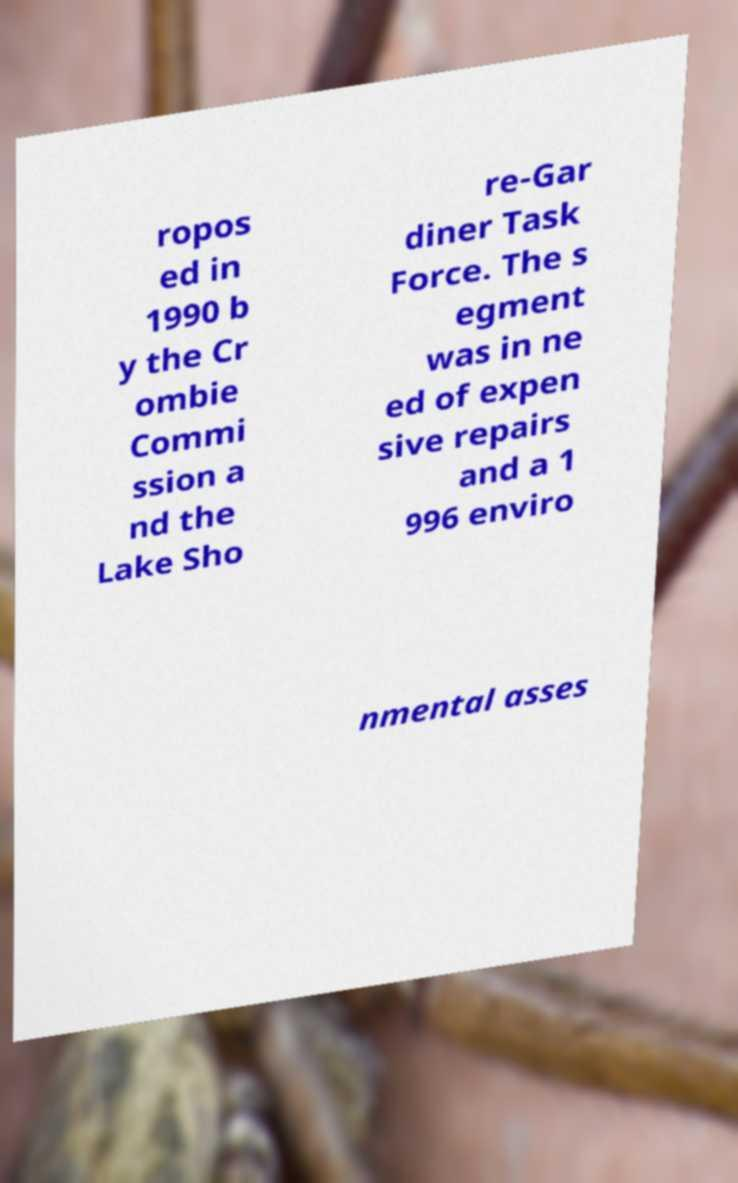I need the written content from this picture converted into text. Can you do that? ropos ed in 1990 b y the Cr ombie Commi ssion a nd the Lake Sho re-Gar diner Task Force. The s egment was in ne ed of expen sive repairs and a 1 996 enviro nmental asses 